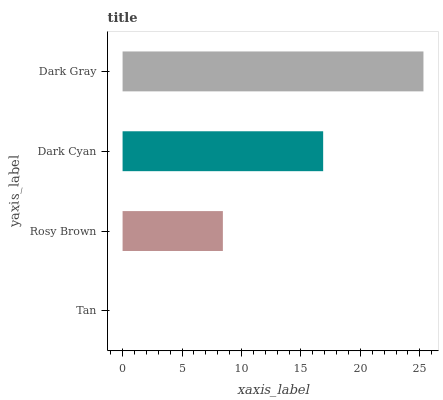Is Tan the minimum?
Answer yes or no. Yes. Is Dark Gray the maximum?
Answer yes or no. Yes. Is Rosy Brown the minimum?
Answer yes or no. No. Is Rosy Brown the maximum?
Answer yes or no. No. Is Rosy Brown greater than Tan?
Answer yes or no. Yes. Is Tan less than Rosy Brown?
Answer yes or no. Yes. Is Tan greater than Rosy Brown?
Answer yes or no. No. Is Rosy Brown less than Tan?
Answer yes or no. No. Is Dark Cyan the high median?
Answer yes or no. Yes. Is Rosy Brown the low median?
Answer yes or no. Yes. Is Tan the high median?
Answer yes or no. No. Is Tan the low median?
Answer yes or no. No. 